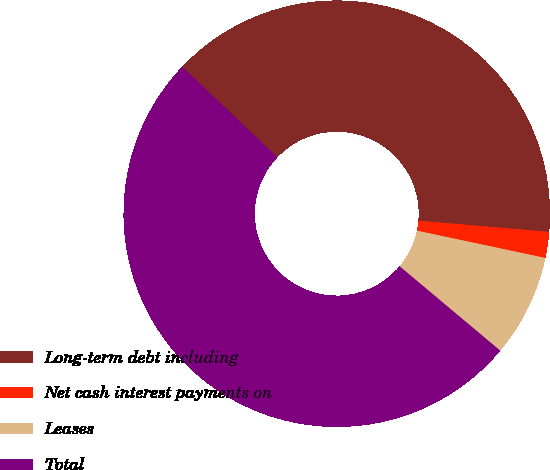Convert chart. <chart><loc_0><loc_0><loc_500><loc_500><pie_chart><fcel>Long-term debt including<fcel>Net cash interest payments on<fcel>Leases<fcel>Total<nl><fcel>39.27%<fcel>1.97%<fcel>7.77%<fcel>50.99%<nl></chart> 